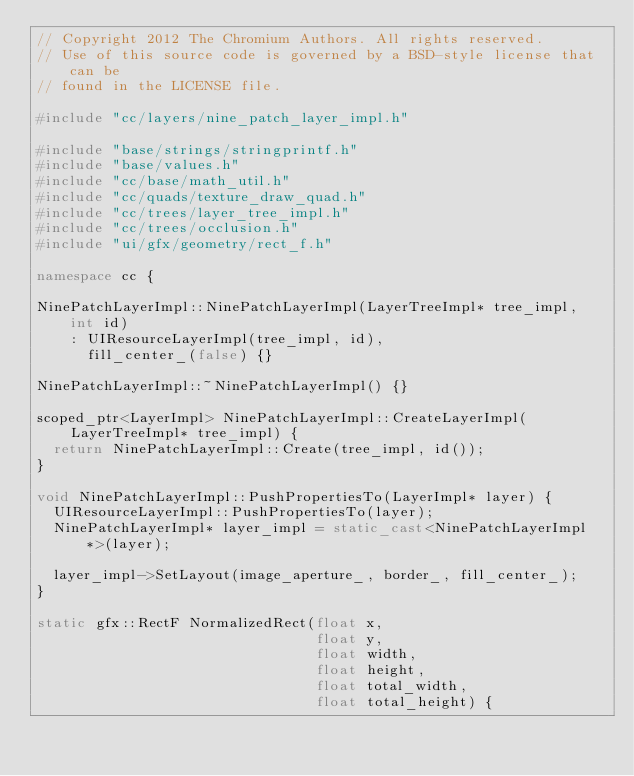Convert code to text. <code><loc_0><loc_0><loc_500><loc_500><_C++_>// Copyright 2012 The Chromium Authors. All rights reserved.
// Use of this source code is governed by a BSD-style license that can be
// found in the LICENSE file.

#include "cc/layers/nine_patch_layer_impl.h"

#include "base/strings/stringprintf.h"
#include "base/values.h"
#include "cc/base/math_util.h"
#include "cc/quads/texture_draw_quad.h"
#include "cc/trees/layer_tree_impl.h"
#include "cc/trees/occlusion.h"
#include "ui/gfx/geometry/rect_f.h"

namespace cc {

NinePatchLayerImpl::NinePatchLayerImpl(LayerTreeImpl* tree_impl, int id)
    : UIResourceLayerImpl(tree_impl, id),
      fill_center_(false) {}

NinePatchLayerImpl::~NinePatchLayerImpl() {}

scoped_ptr<LayerImpl> NinePatchLayerImpl::CreateLayerImpl(
    LayerTreeImpl* tree_impl) {
  return NinePatchLayerImpl::Create(tree_impl, id());
}

void NinePatchLayerImpl::PushPropertiesTo(LayerImpl* layer) {
  UIResourceLayerImpl::PushPropertiesTo(layer);
  NinePatchLayerImpl* layer_impl = static_cast<NinePatchLayerImpl*>(layer);

  layer_impl->SetLayout(image_aperture_, border_, fill_center_);
}

static gfx::RectF NormalizedRect(float x,
                                 float y,
                                 float width,
                                 float height,
                                 float total_width,
                                 float total_height) {</code> 